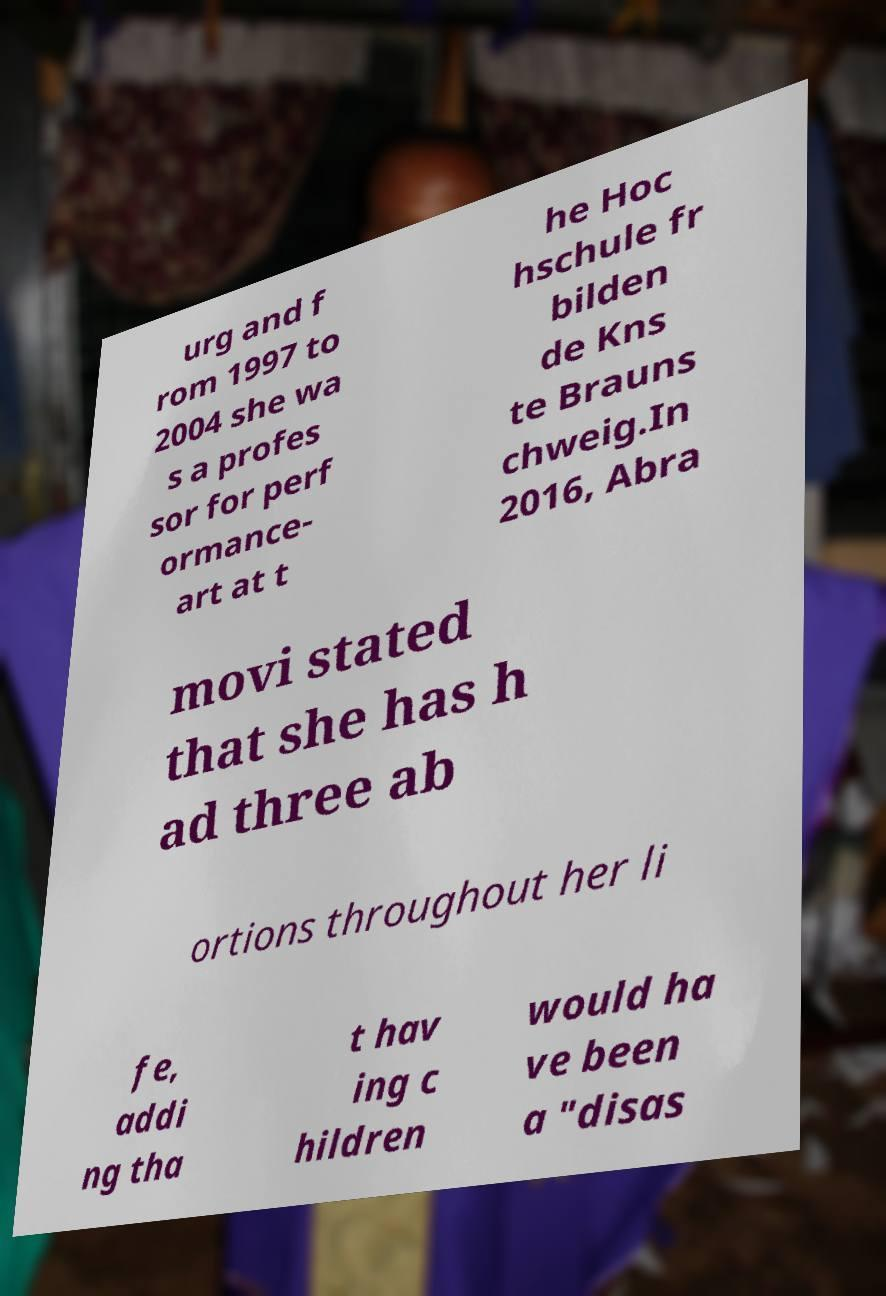Could you assist in decoding the text presented in this image and type it out clearly? urg and f rom 1997 to 2004 she wa s a profes sor for perf ormance- art at t he Hoc hschule fr bilden de Kns te Brauns chweig.In 2016, Abra movi stated that she has h ad three ab ortions throughout her li fe, addi ng tha t hav ing c hildren would ha ve been a "disas 